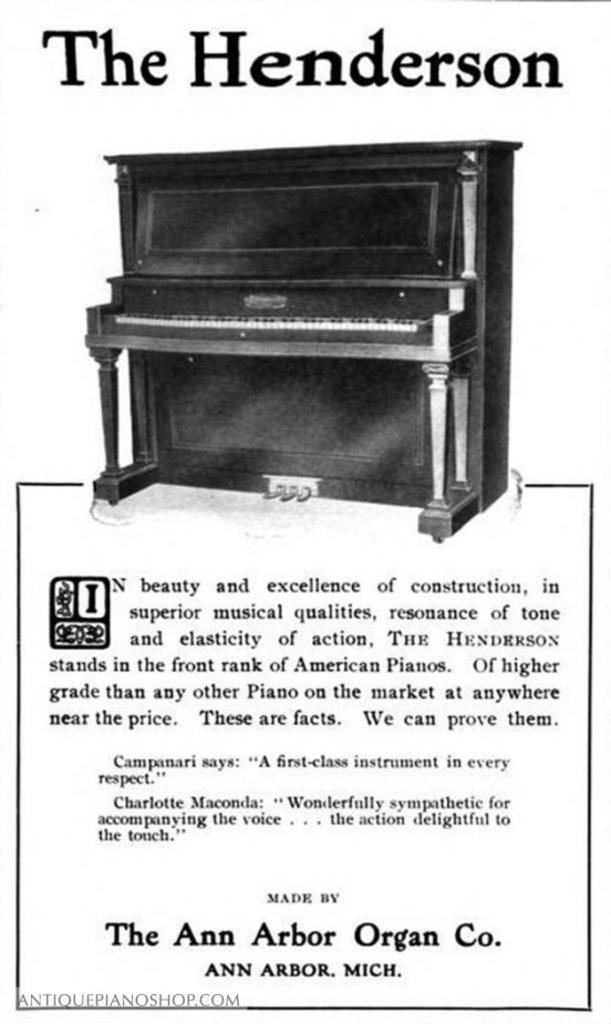In one or two sentences, can you explain what this image depicts? In this image there is a poster having some picture and text. There is a piano at the middle of image. Bottom of the image there is some text. Top of the image there is some text in bold letters. 